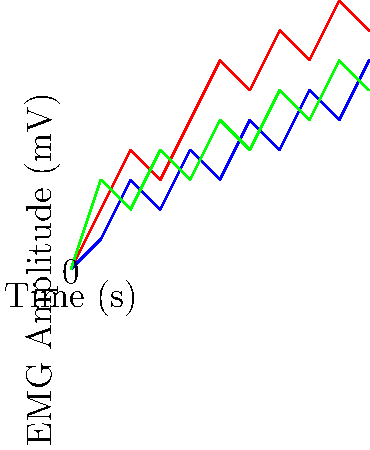As a fitness influencer interested in featuring a young fighter's training regimen, you're analyzing EMG data from their boxing session. The graph shows EMG signal patterns from three major muscle groups during a 10-second period of intense punching. Which muscle group shows the highest peak activation, and what does this suggest about the fighter's technique? To answer this question, we need to analyze the EMG signal patterns for each muscle group:

1. Biceps (red line):
   - Peaks at approximately 9 mV
   - Shows consistent activation throughout the session

2. Triceps (blue line):
   - Peaks at approximately 7 mV
   - Shows a gradual increase in activation over time

3. Deltoids (green line):
   - Peaks at approximately 7 mV
   - Shows variable activation with frequent peaks and troughs

Comparing the peak activations:
- Biceps: 9 mV
- Triceps: 7 mV
- Deltoids: 7 mV

The biceps show the highest peak activation at 9 mV.

This suggests that the fighter's technique involves significant bicep engagement during punching. In boxing, the biceps are primarily used for:
1. Retracting the arm after a punch
2. Assisting in hook punches
3. Maintaining guard position

The high bicep activation could indicate that the fighter:
- Relies heavily on hook punches
- Focuses on quick arm retraction for defensive purposes
- Maintains a tight guard position throughout the session

It's important to note that while bicep activation is high, a well-rounded boxing technique should involve balanced activation of all three muscle groups. The fighter might benefit from exercises to improve tricep and deltoid engagement for more powerful straight punches and improved shoulder stability.
Answer: Biceps; suggests emphasis on hooks, quick retractions, or tight guard. 